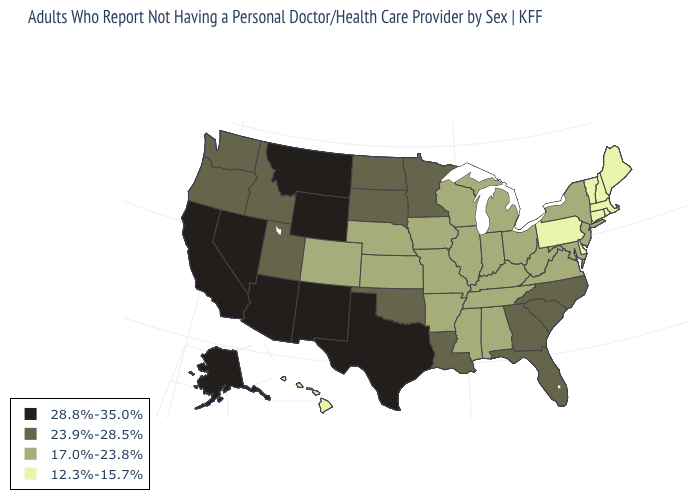Which states have the lowest value in the USA?
Short answer required. Connecticut, Delaware, Hawaii, Maine, Massachusetts, New Hampshire, Pennsylvania, Rhode Island, Vermont. What is the value of North Dakota?
Keep it brief. 23.9%-28.5%. What is the value of Montana?
Quick response, please. 28.8%-35.0%. Does the first symbol in the legend represent the smallest category?
Quick response, please. No. Name the states that have a value in the range 28.8%-35.0%?
Short answer required. Alaska, Arizona, California, Montana, Nevada, New Mexico, Texas, Wyoming. How many symbols are there in the legend?
Give a very brief answer. 4. What is the value of Rhode Island?
Short answer required. 12.3%-15.7%. Does the first symbol in the legend represent the smallest category?
Answer briefly. No. Which states hav the highest value in the West?
Be succinct. Alaska, Arizona, California, Montana, Nevada, New Mexico, Wyoming. What is the value of Ohio?
Short answer required. 17.0%-23.8%. Name the states that have a value in the range 28.8%-35.0%?
Give a very brief answer. Alaska, Arizona, California, Montana, Nevada, New Mexico, Texas, Wyoming. What is the value of Illinois?
Be succinct. 17.0%-23.8%. Does Washington have a lower value than Texas?
Be succinct. Yes. Name the states that have a value in the range 23.9%-28.5%?
Answer briefly. Florida, Georgia, Idaho, Louisiana, Minnesota, North Carolina, North Dakota, Oklahoma, Oregon, South Carolina, South Dakota, Utah, Washington. 